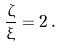Convert formula to latex. <formula><loc_0><loc_0><loc_500><loc_500>\frac { \zeta } { \xi } = 2 \, .</formula> 